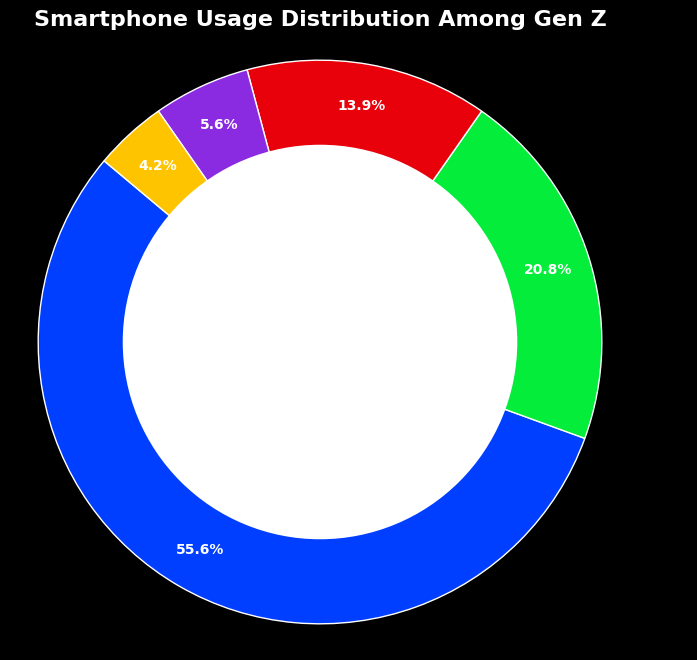What's the most used category among Gen Z for smartphone usage? The ring chart shows that Social Media occupies the largest portion of the chart, thus indicating it is the most used category.
Answer: Social Media Which category is used more, Gaming or Productivity? By comparing the respective segments: Gaming is 15% and Productivity is 10%. Since 15% is greater than 10%, Gaming is used more.
Answer: Gaming What is the combined percentage of time spent on Shopping and Others? In the ring chart, Shopping is 4% and Others is 3%. Adding these gives 4% + 3% = 7%.
Answer: 7% How does the use of Social Media compare to Gaming and Productivity combined? The percentage for Social Media is 40%. Added percentages for Gaming and Productivity are 15% + 10% = 25%. Since 40% is greater than 25%, Social Media is used more than Gaming and Productivity combined.
Answer: Social Media is used more Which category has the smallest usage percentage among Gen Z? From the chart, Others has the smallest segment with 3% usage.
Answer: Others How much more time is spent on Social Media than on Productivity? Social Media accounts for 40% while Productivity is 10%. Subtracting these gives 40% - 10% = 30%.
Answer: 30% What is the difference in the percentage between Gaming and Shopping? Gaming is 15% and Shopping is 4%. The difference is 15% - 4% = 11%.
Answer: 11% Is the percentage of time spent on Social Media greater than the sum of Shopping and Others? Social Media is 40%. Sum of Shopping and Others is 4% + 3% = 7%. Since 40% is greater than 7%, it is greater.
Answer: Yes If you combine the percentages for Gaming, Productivity, and Shopping, what would it be? Adding Gaming (15%), Productivity (10%), and Shopping (4%) gives 15% + 10% + 4% = 29%.
Answer: 29% Which category’s usage percentage falls between Shopping and Productivity? Shopping is 4% and Productivity is 10%, and the category in between is Gaming with 15%.
Answer: Gaming 